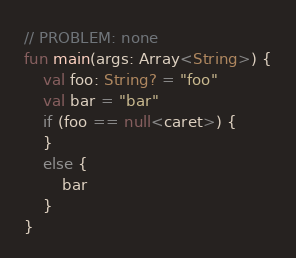<code> <loc_0><loc_0><loc_500><loc_500><_Kotlin_>// PROBLEM: none
fun main(args: Array<String>) {
    val foo: String? = "foo"
    val bar = "bar"
    if (foo == null<caret>) {
    }
    else {
        bar
    }
}
</code> 